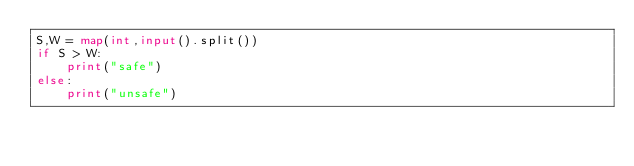<code> <loc_0><loc_0><loc_500><loc_500><_Python_>S,W = map(int,input().split())
if S > W:
    print("safe")
else:
    print("unsafe")</code> 